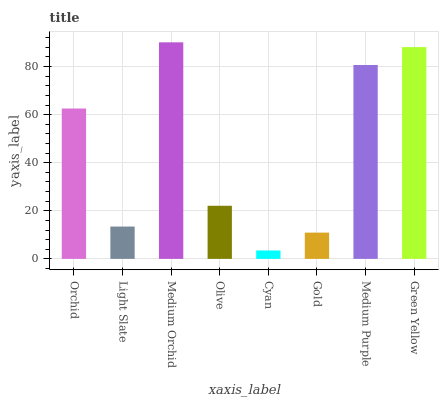Is Cyan the minimum?
Answer yes or no. Yes. Is Medium Orchid the maximum?
Answer yes or no. Yes. Is Light Slate the minimum?
Answer yes or no. No. Is Light Slate the maximum?
Answer yes or no. No. Is Orchid greater than Light Slate?
Answer yes or no. Yes. Is Light Slate less than Orchid?
Answer yes or no. Yes. Is Light Slate greater than Orchid?
Answer yes or no. No. Is Orchid less than Light Slate?
Answer yes or no. No. Is Orchid the high median?
Answer yes or no. Yes. Is Olive the low median?
Answer yes or no. Yes. Is Medium Orchid the high median?
Answer yes or no. No. Is Medium Orchid the low median?
Answer yes or no. No. 